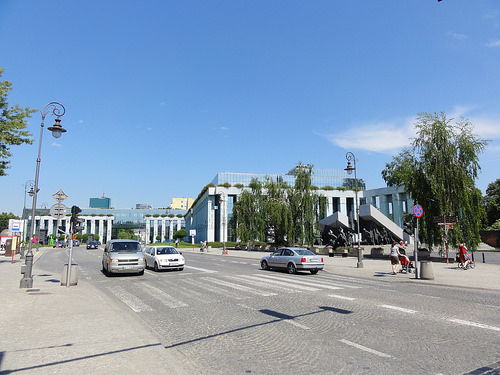<image>
Is there a this car next to the that car? No. The this car is not positioned next to the that car. They are located in different areas of the scene. 